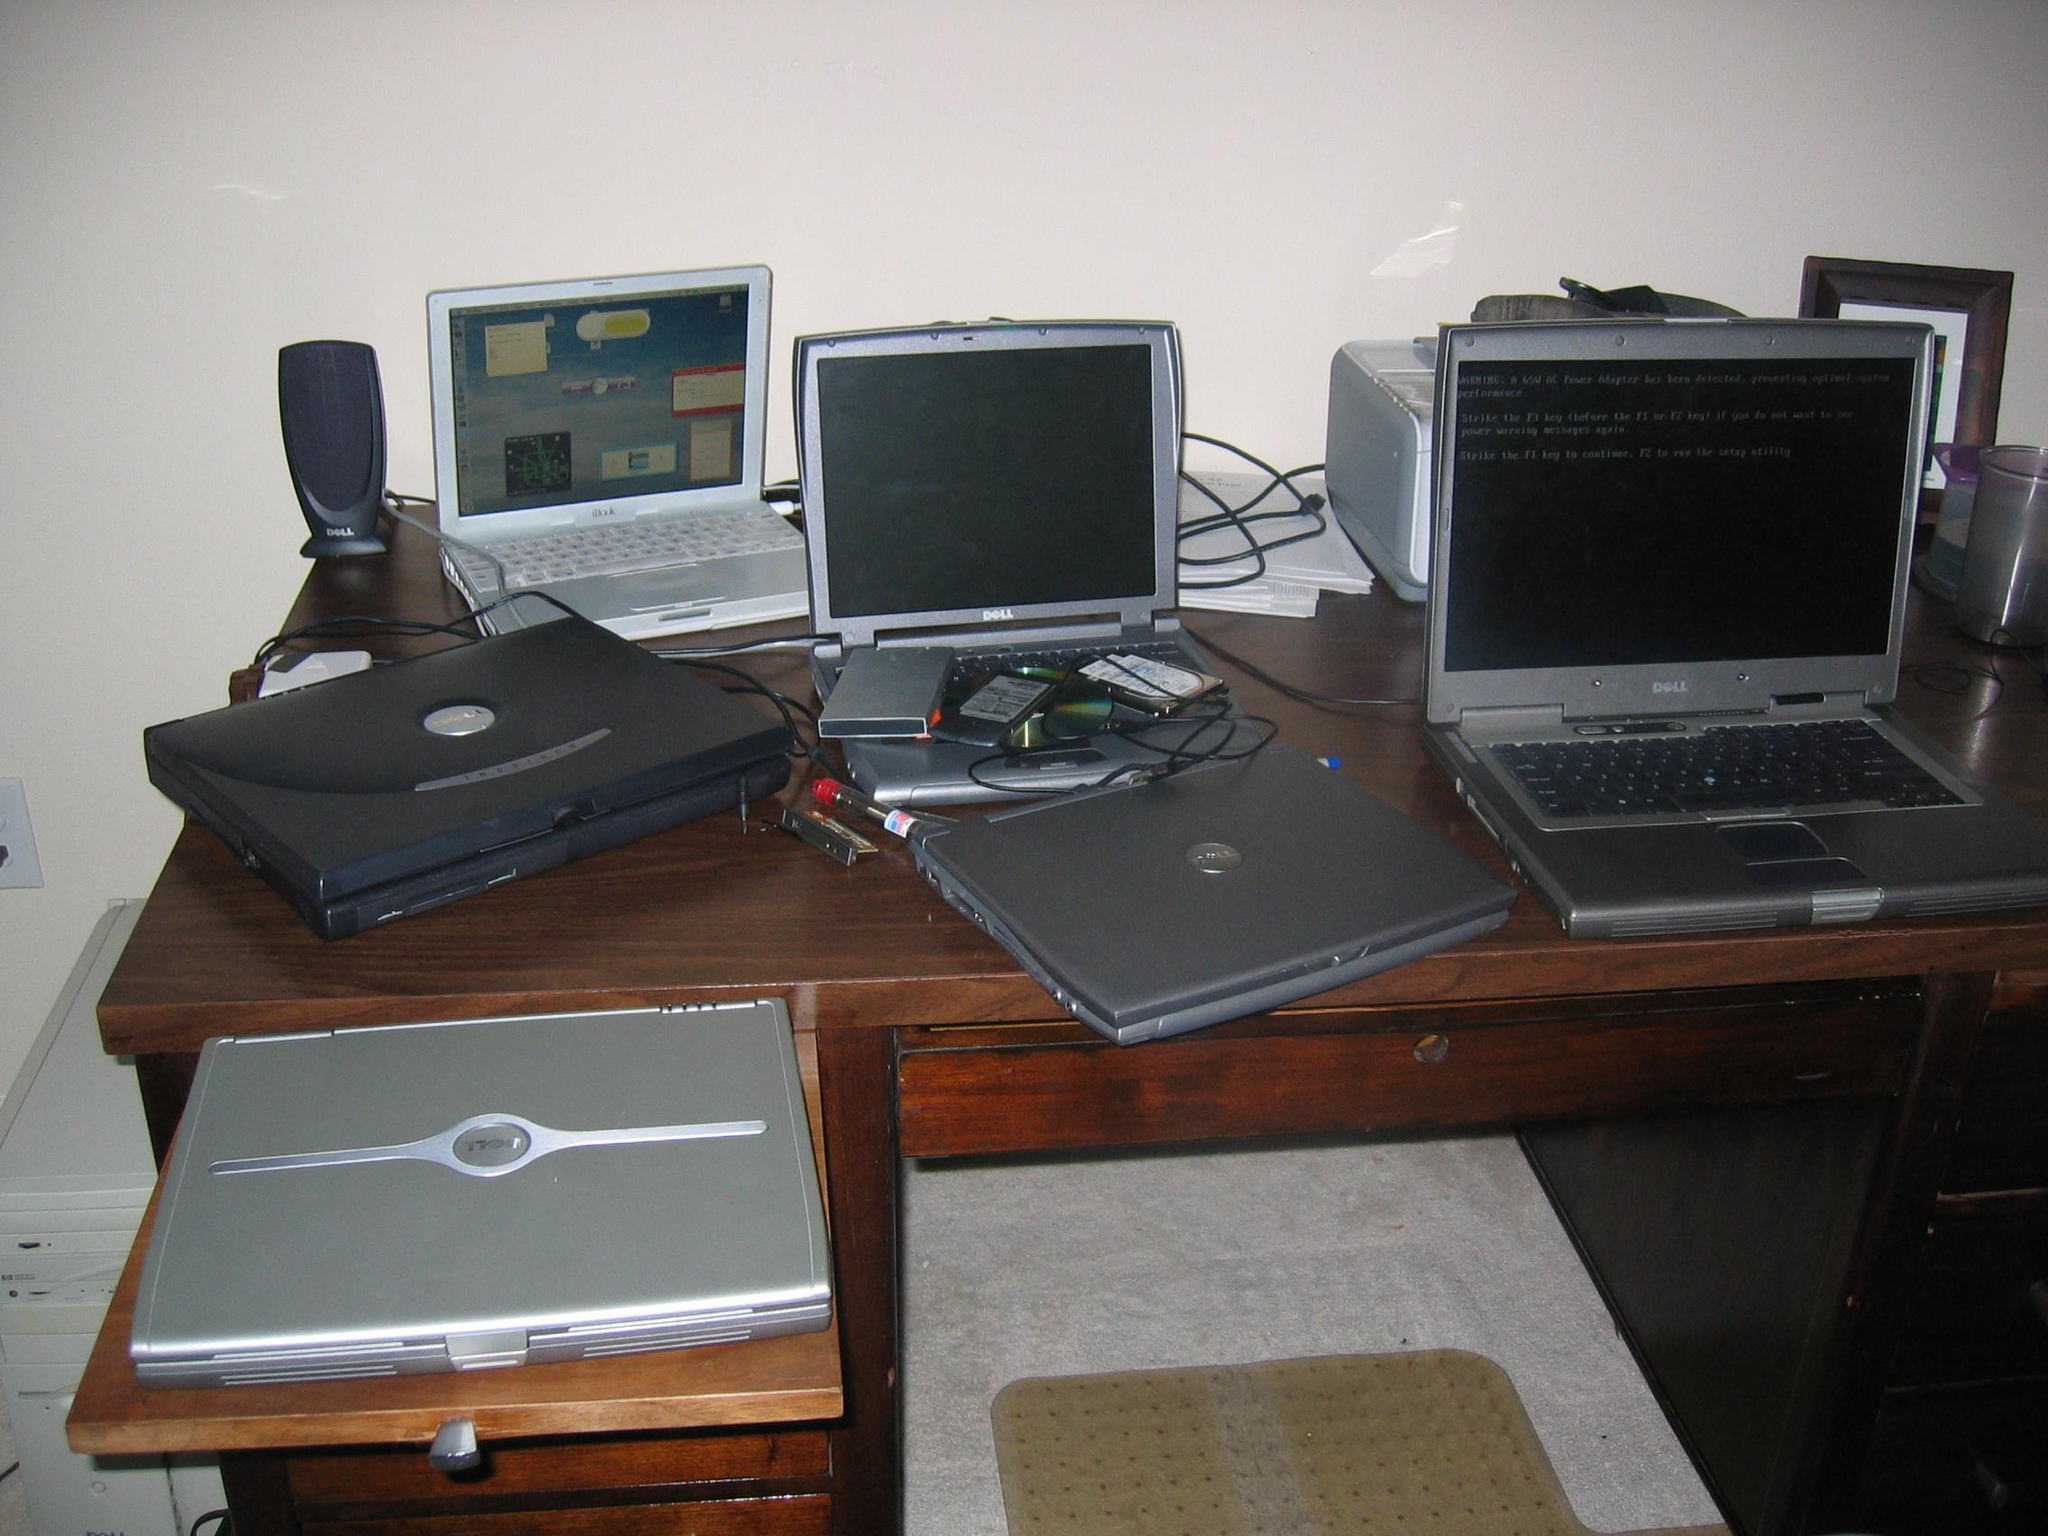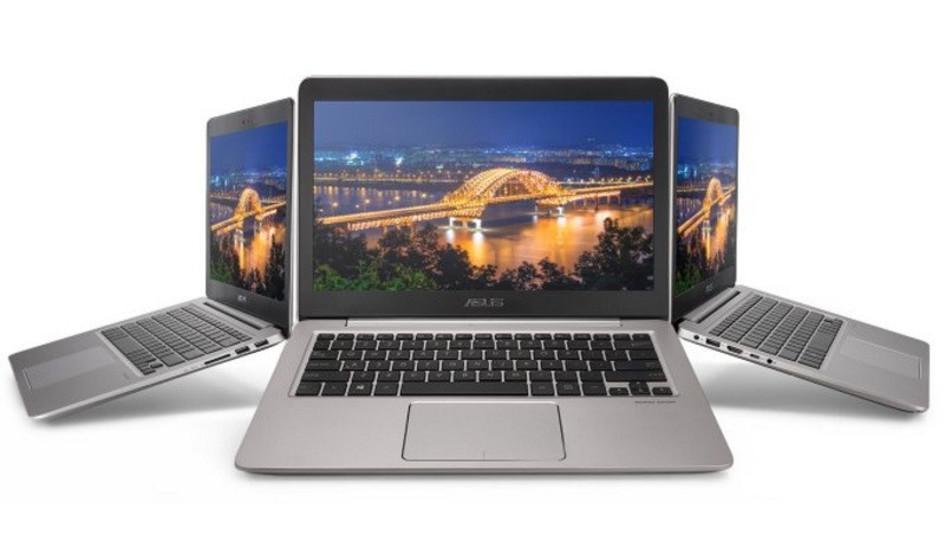The first image is the image on the left, the second image is the image on the right. Assess this claim about the two images: "One image shows a brown desk with three computer screens visible on top of it.". Correct or not? Answer yes or no. Yes. The first image is the image on the left, the second image is the image on the right. Examine the images to the left and right. Is the description "Three computers are displayed in the image on the right." accurate? Answer yes or no. Yes. 